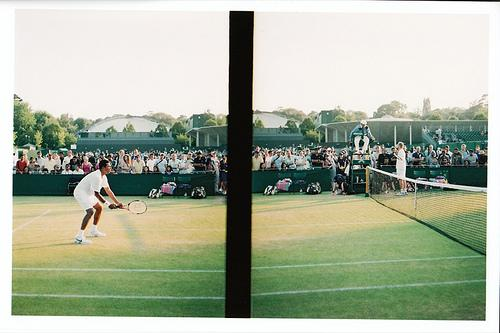What can you say about the overall mood of the image based on the objects and elements in it?  The image is lively and action-filled, depicting an ongoing tennis match with focused players, and engaged spectators. How many bags are there on the ground or on the sidelines, and what is their purpose? There are several bags on the ground and sidelines, which presumably belong to the tennis players and store their gear and belongings. What can be inferred about the profile of the people in the image. The people in the image are likely athletes, spectators, and a referee, all focused on a tennis match and its outcome. How many people are wearing white in the image, and what is their relevance to the game of tennis? There are several people wearing white, including the main tennis player, and others in the background. White is a traditional tennis attire color, indicating their involvement in the sport. List all the objects related to tennis visible in the image. Tennis racket, tennis net, tennis court, white lines on court, white shoes, and sweatband on arm. What do you think is the purpose of the white lines on the tennis court? The white lines on the tennis court define the sport-specific playing boundaries and areas, allowing for proper gameplay and scoring. What role do the objects located around the tennis court play in the context of the image? The objects around the tennis court, such as bags, referee stand, and trees, add context and detail to the scene, providing a more realistic environment for the match. Identify the subject that interacts with the referee and explain their possible intentions. Someone is speaking with the referee, possibly to clarify a rule, discuss a decision or make an inquiry related to the match. Identify the primary action and the main subject performing it in the image. A man holding a tennis racket is the main subject in the image, and he is standing on a tennis court. What would you assess the image quality, based on the level of detail and clarity of the objects in the image? The image quality appears to be good, as it provides a clear and detailed representation of the objects, people, and elements within the scene. What is the atmosphere of the scene as shown by the image? Competitive and eventful List all the objects in the image and their locations. Tennis player: X:58 Y:163 Width:96 Height:96; Identify any text present in the image. There is no text present in the image. Identify the attributes of the tennis player's shoes. White color Locate the referee in the image. X:349 Y:114 Width:36 Height:36 Find the dog on the tennis court. No, it's not mentioned in the image. What is the average percentage of width and height for spectators in the audience? Width: 96.5% Height: 96.5% Which bag is the red one among the bags on the ground? None of the bags in the image have a specified color, so it is misleading to ask for a red one. Identify objects on the sidelines of the court. Bags on the ground Determine the position of the tennis net that separates the sides. X:360 Y:162 Width:128 Height:128 Describe the clothing of the tennis player. The tennis player is wearing white. Find any anomalies in the image. No significant anomalies are present in the image. Analyze the interaction between the tennis player and his racket. The tennis player is holding the racket, actively engaged in play. Evaluate the quality of the image. The image has clear object representations and adequately captures the nature of the scene. Describe the main objects and events happening in the image. A man holding a tennis racket is playing tennis on a green court with white lines. Spectators are watching the game, and a referee is sitting in a chair overseeing the match. Locate the boundaries of different elements in the image like the tennis court, net, and audience. Tennis court: X:280 Y:216 Width:120 Height:120;  Which color is the referee's stand? Green Connect the description "man holding a tennis racket" to the corresponding object in the image. X:58 Y:163 Width:96 Height:96 Where is the woman wearing a white outfit on the tennis court? All the mentioned characters in the image are men, so asking about a woman wearing a white outfit is misleading. Which tree is the largest in the background? There is just mention of the presence of trees in the background, without any details about their size, so asking for the largest tree is misleading. Who is the basketball player in the image? The image is about a tennis match and there is no mention of basketball players, so this question is misleading. 